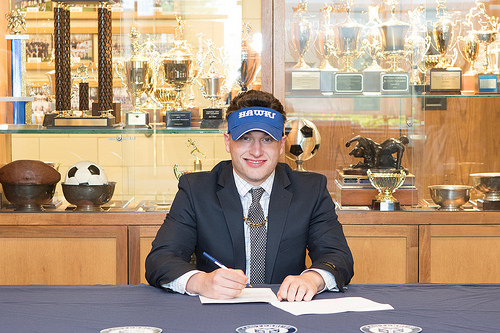<image>
Can you confirm if the ball is behind the man? Yes. From this viewpoint, the ball is positioned behind the man, with the man partially or fully occluding the ball. Where is the man in relation to the ball? Is it in front of the ball? Yes. The man is positioned in front of the ball, appearing closer to the camera viewpoint. Is there a ball in front of the man? No. The ball is not in front of the man. The spatial positioning shows a different relationship between these objects. 